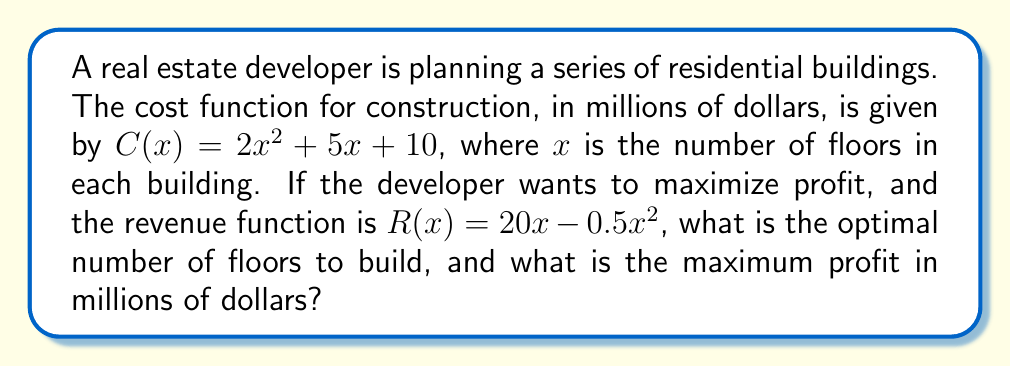Provide a solution to this math problem. 1) To find the optimal number of floors, we need to maximize the profit function. Profit (P) is revenue minus cost:

   $P(x) = R(x) - C(x) = (20x - 0.5x^2) - (2x^2 + 5x + 10)$

2) Simplify the profit function:

   $P(x) = -2.5x^2 + 15x - 10$

3) To find the maximum, we differentiate P(x) and set it to zero:

   $$\frac{dP}{dx} = -5x + 15 = 0$$

4) Solve for x:

   $-5x = -15$
   $x = 3$

5) Verify this is a maximum by checking the second derivative is negative:

   $$\frac{d^2P}{dx^2} = -5 < 0$$

6) Therefore, the optimal number of floors is 3.

7) Calculate the maximum profit by substituting x = 3 into P(x):

   $P(3) = -2.5(3^2) + 15(3) - 10$
   $= -22.5 + 45 - 10$
   $= 12.5$

Thus, the maximum profit is $12.5 million.
Answer: 3 floors; $12.5 million 